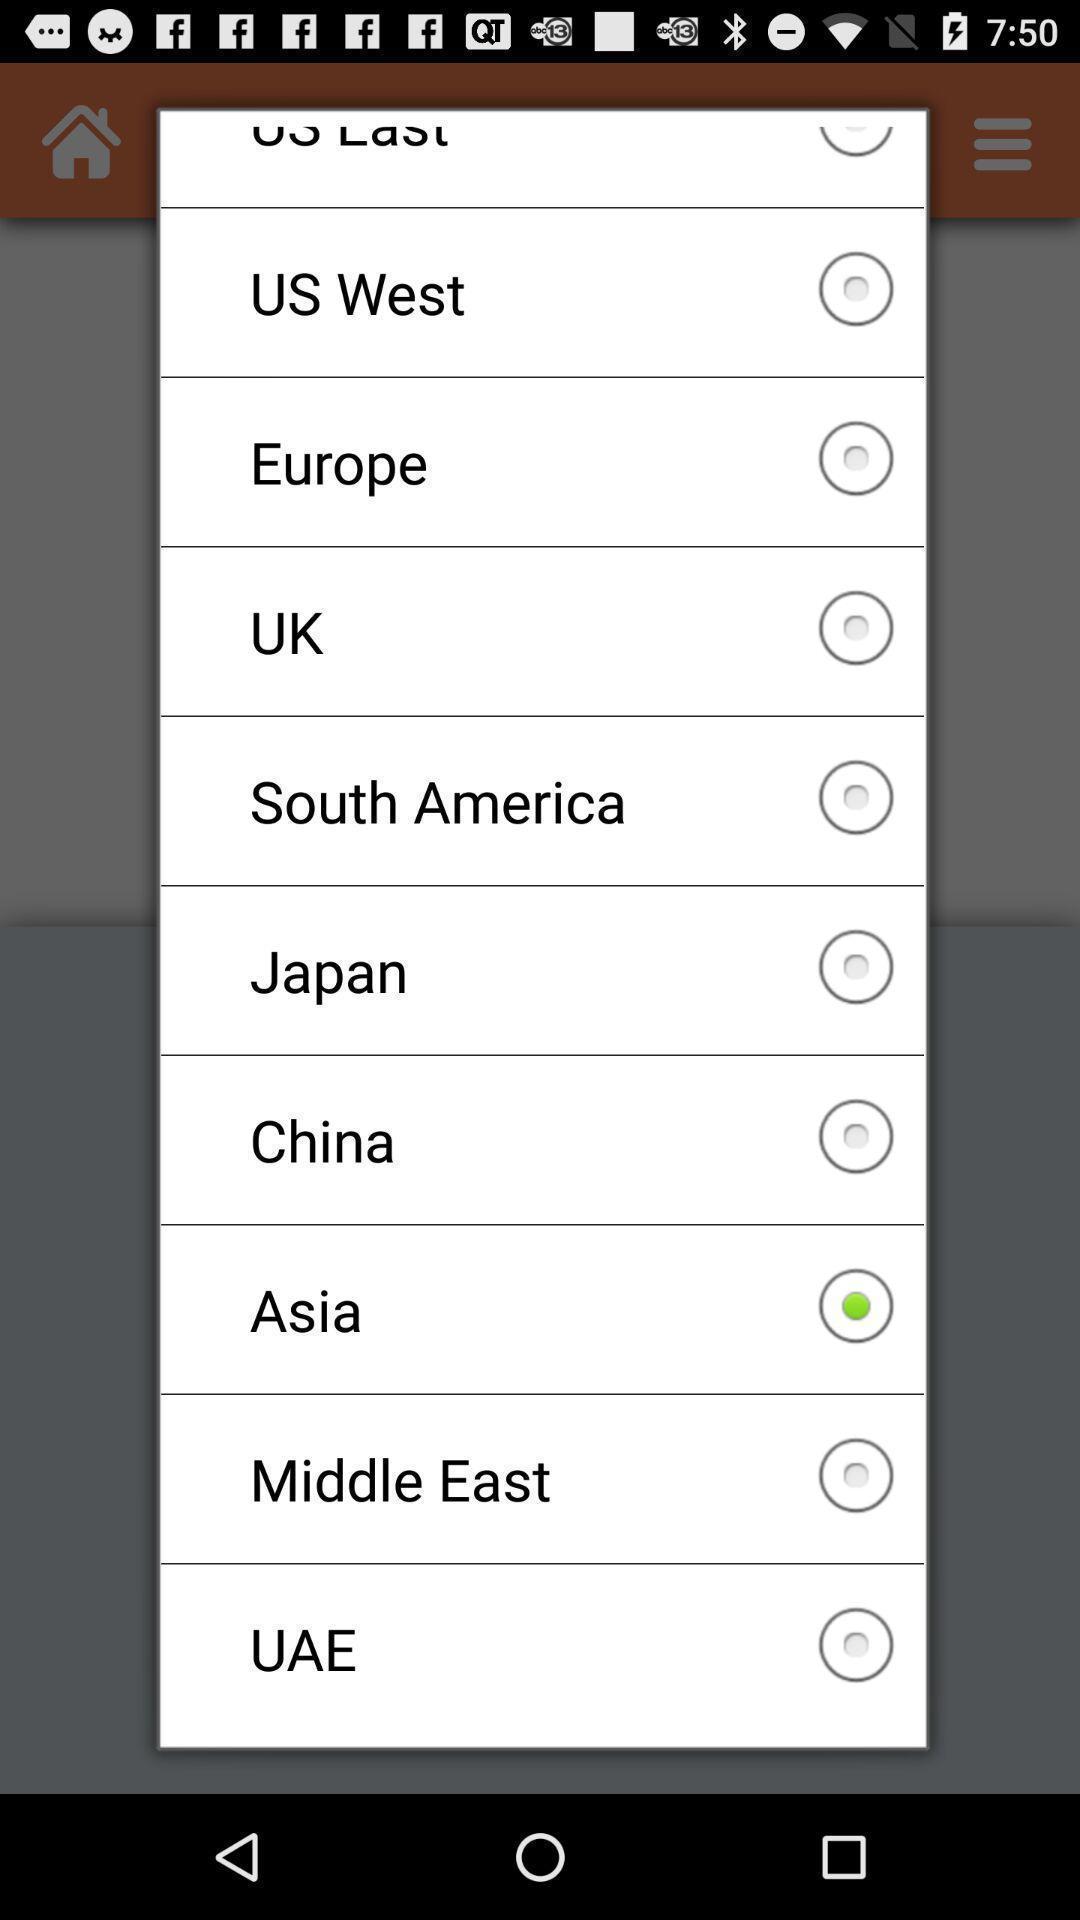Describe the key features of this screenshot. Popup of various countries in the application. 